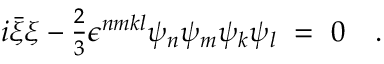<formula> <loc_0><loc_0><loc_500><loc_500>i \bar { \xi } \xi - { \frac { 2 } { 3 } } \epsilon ^ { n m k l } \psi _ { n } \psi _ { m } \psi _ { k } \psi _ { l } \ = \ 0 \quad .</formula> 